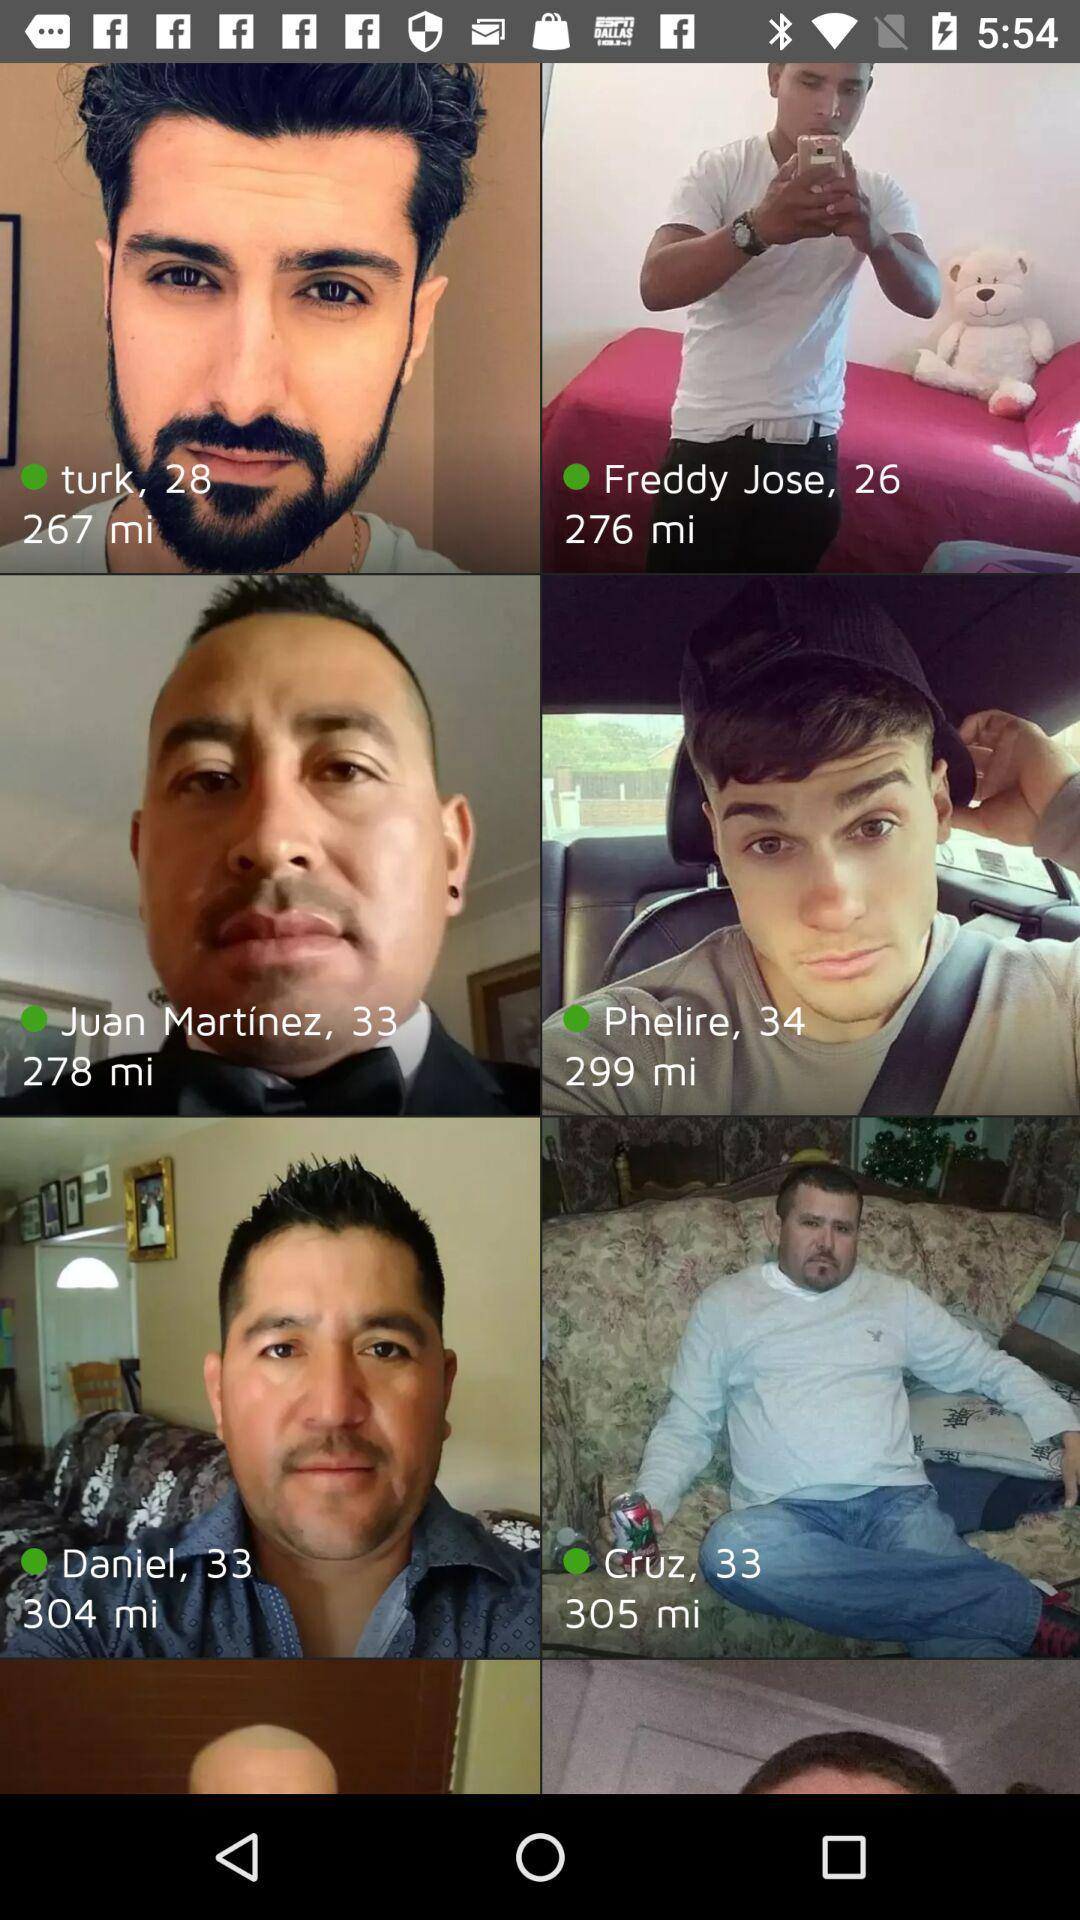What is the age of Cruz? Cruz's age is 33 years old. 